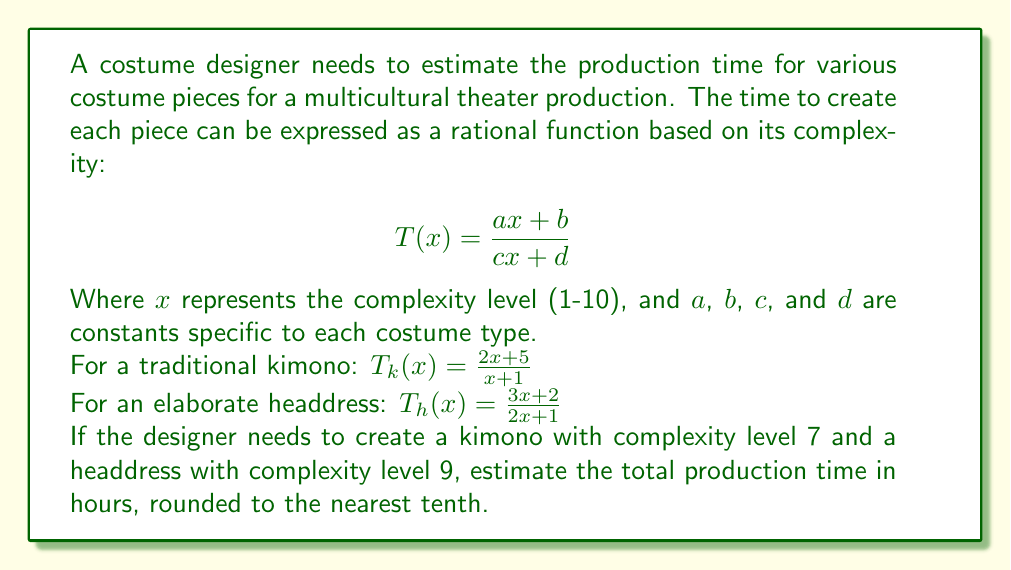Can you answer this question? Let's approach this step-by-step:

1. For the kimono with complexity level 7:
   $$T_k(7) = \frac{2(7) + 5}{7 + 1} = \frac{14 + 5}{8} = \frac{19}{8} = 2.375 \text{ hours}$$

2. For the headdress with complexity level 9:
   $$T_h(9) = \frac{3(9) + 2}{2(9) + 1} = \frac{27 + 2}{18 + 1} = \frac{29}{19} \approx 1.526 \text{ hours}$$

3. Total production time:
   $$T_{total} = T_k(7) + T_h(9) = 2.375 + 1.526 = 3.901 \text{ hours}$$

4. Rounding to the nearest tenth:
   $$3.901 \approx 3.9 \text{ hours}$$
Answer: 3.9 hours 